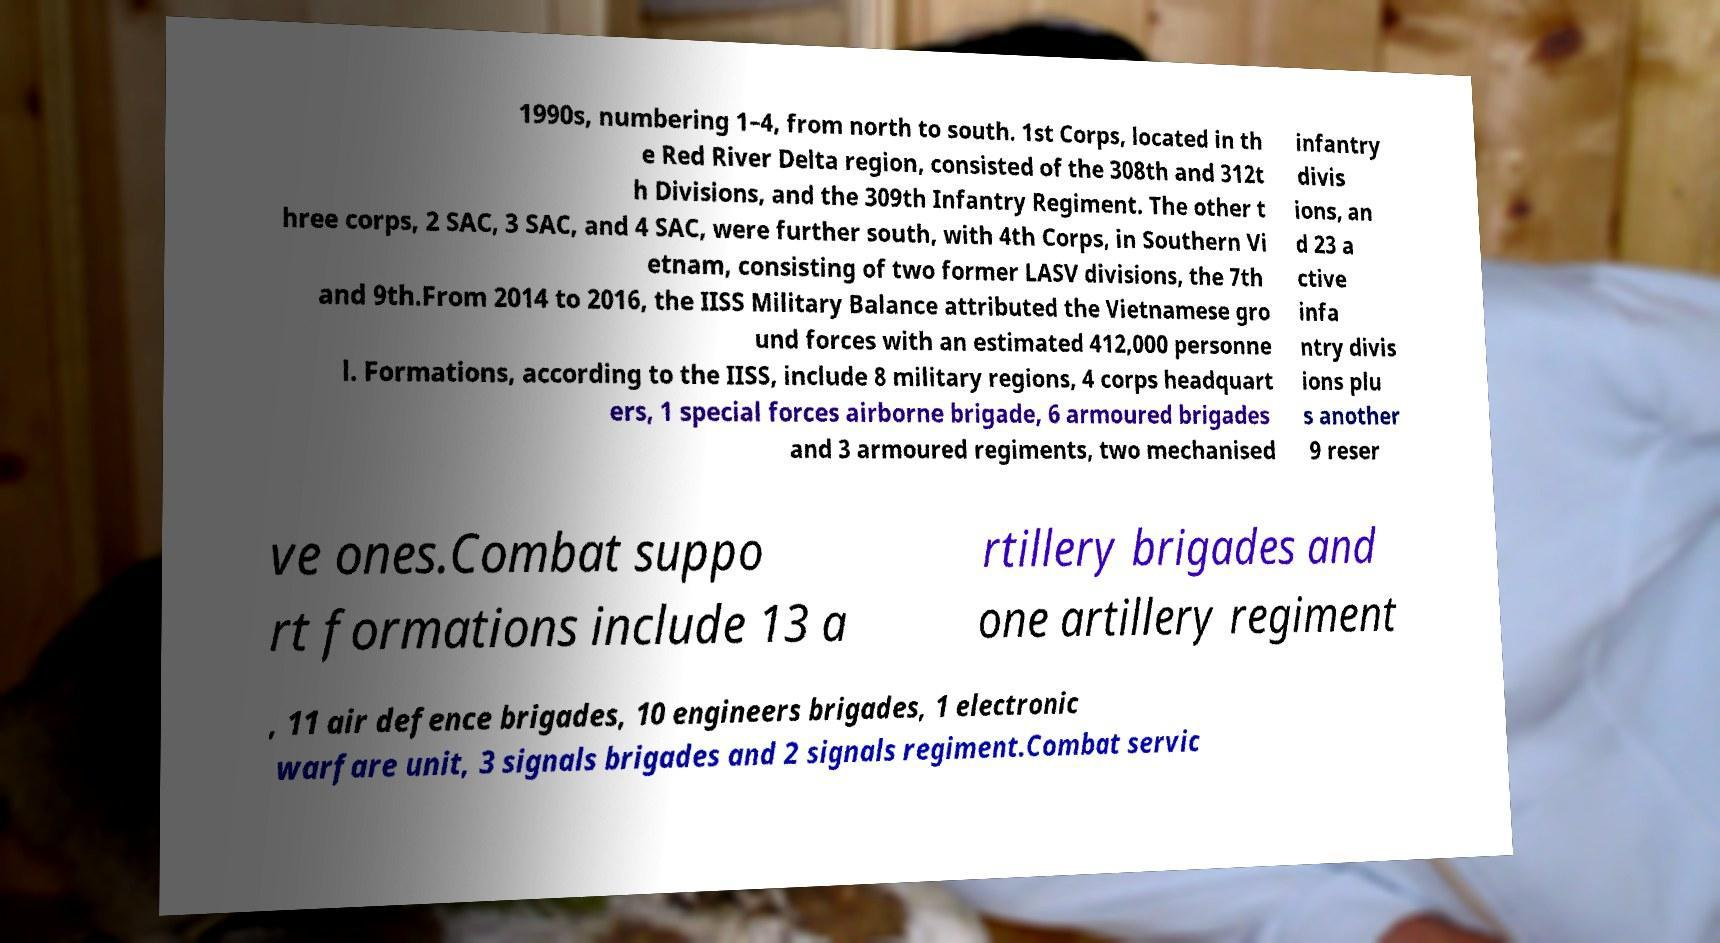Could you extract and type out the text from this image? 1990s, numbering 1–4, from north to south. 1st Corps, located in th e Red River Delta region, consisted of the 308th and 312t h Divisions, and the 309th Infantry Regiment. The other t hree corps, 2 SAC, 3 SAC, and 4 SAC, were further south, with 4th Corps, in Southern Vi etnam, consisting of two former LASV divisions, the 7th and 9th.From 2014 to 2016, the IISS Military Balance attributed the Vietnamese gro und forces with an estimated 412,000 personne l. Formations, according to the IISS, include 8 military regions, 4 corps headquart ers, 1 special forces airborne brigade, 6 armoured brigades and 3 armoured regiments, two mechanised infantry divis ions, an d 23 a ctive infa ntry divis ions plu s another 9 reser ve ones.Combat suppo rt formations include 13 a rtillery brigades and one artillery regiment , 11 air defence brigades, 10 engineers brigades, 1 electronic warfare unit, 3 signals brigades and 2 signals regiment.Combat servic 